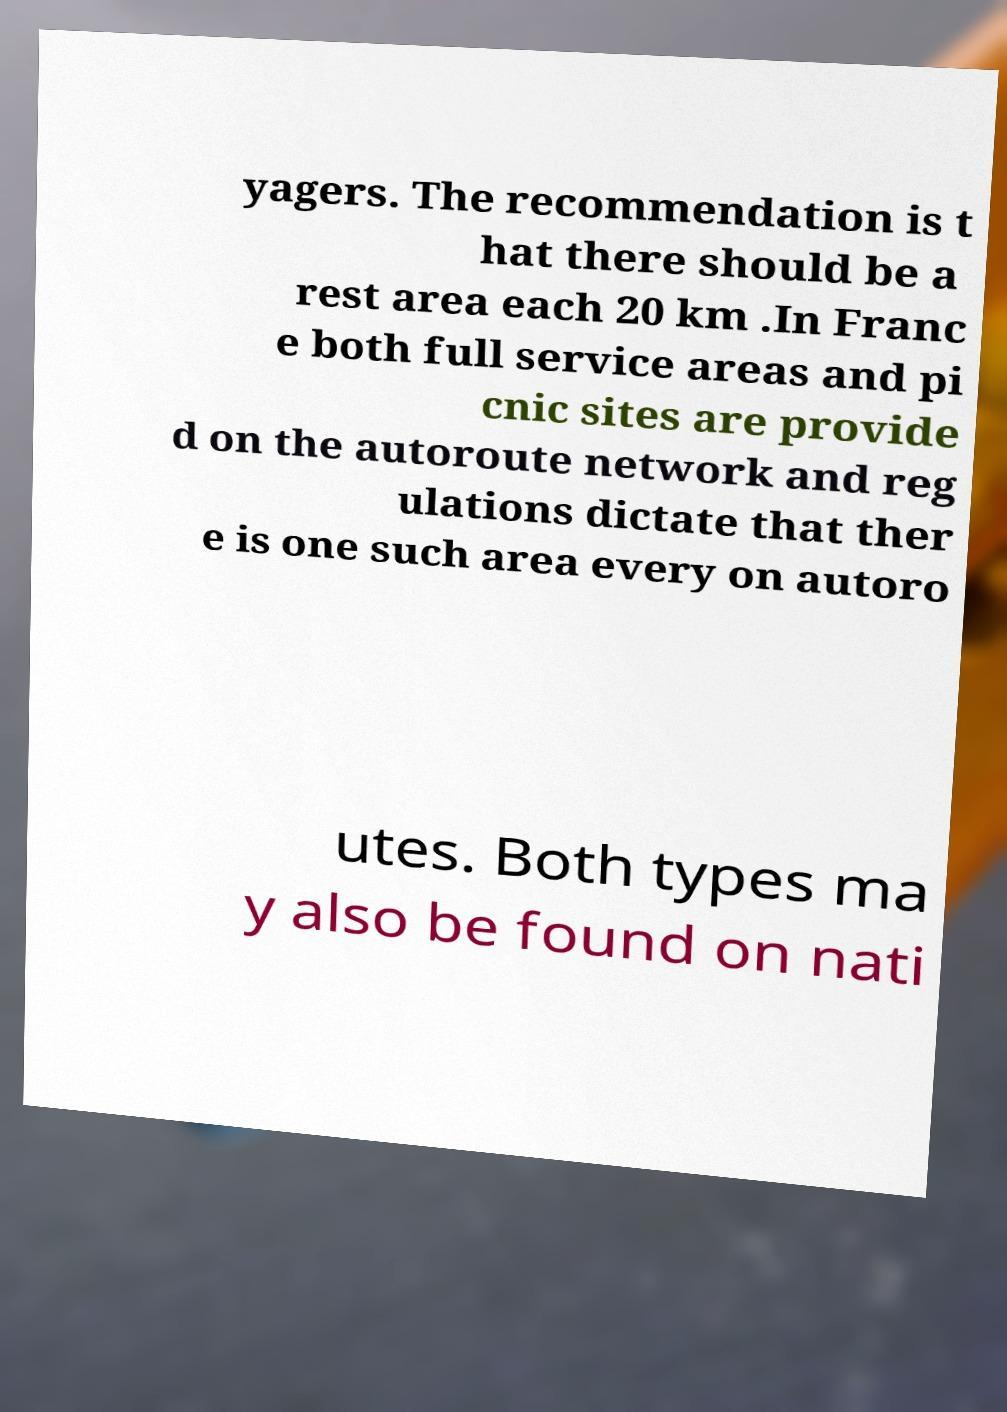Could you assist in decoding the text presented in this image and type it out clearly? yagers. The recommendation is t hat there should be a rest area each 20 km .In Franc e both full service areas and pi cnic sites are provide d on the autoroute network and reg ulations dictate that ther e is one such area every on autoro utes. Both types ma y also be found on nati 